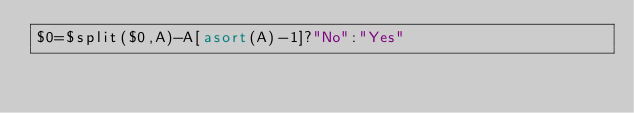<code> <loc_0><loc_0><loc_500><loc_500><_Awk_>$0=$split($0,A)-A[asort(A)-1]?"No":"Yes"</code> 